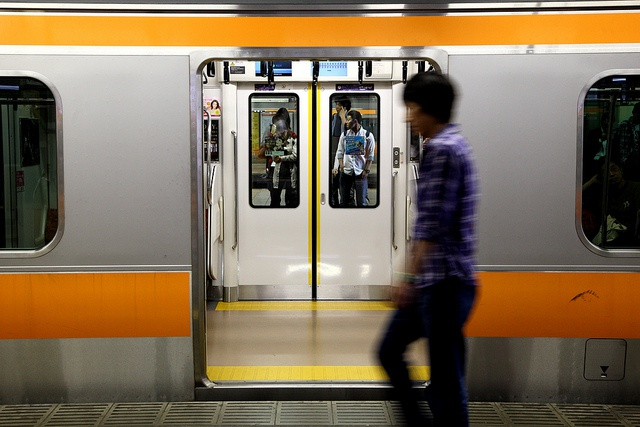Describe the objects in this image and their specific colors. I can see train in gray, black, darkgray, and lightgray tones, people in gray, black, navy, and maroon tones, people in gray, black, and darkgreen tones, people in gray, black, darkgray, and darkgreen tones, and people in gray, black, darkgray, and lightgray tones in this image. 